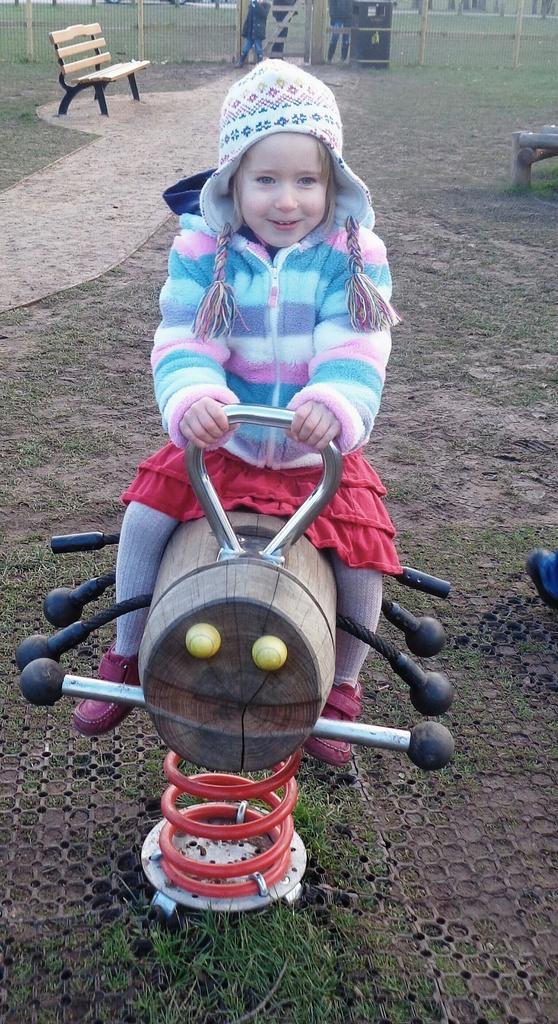Please provide a concise description of this image. In this picture we can see girl wore sweater, cap holding some toy vehicle handler and this is placed on ground and in background we can see bench, fence, path, some persons. 